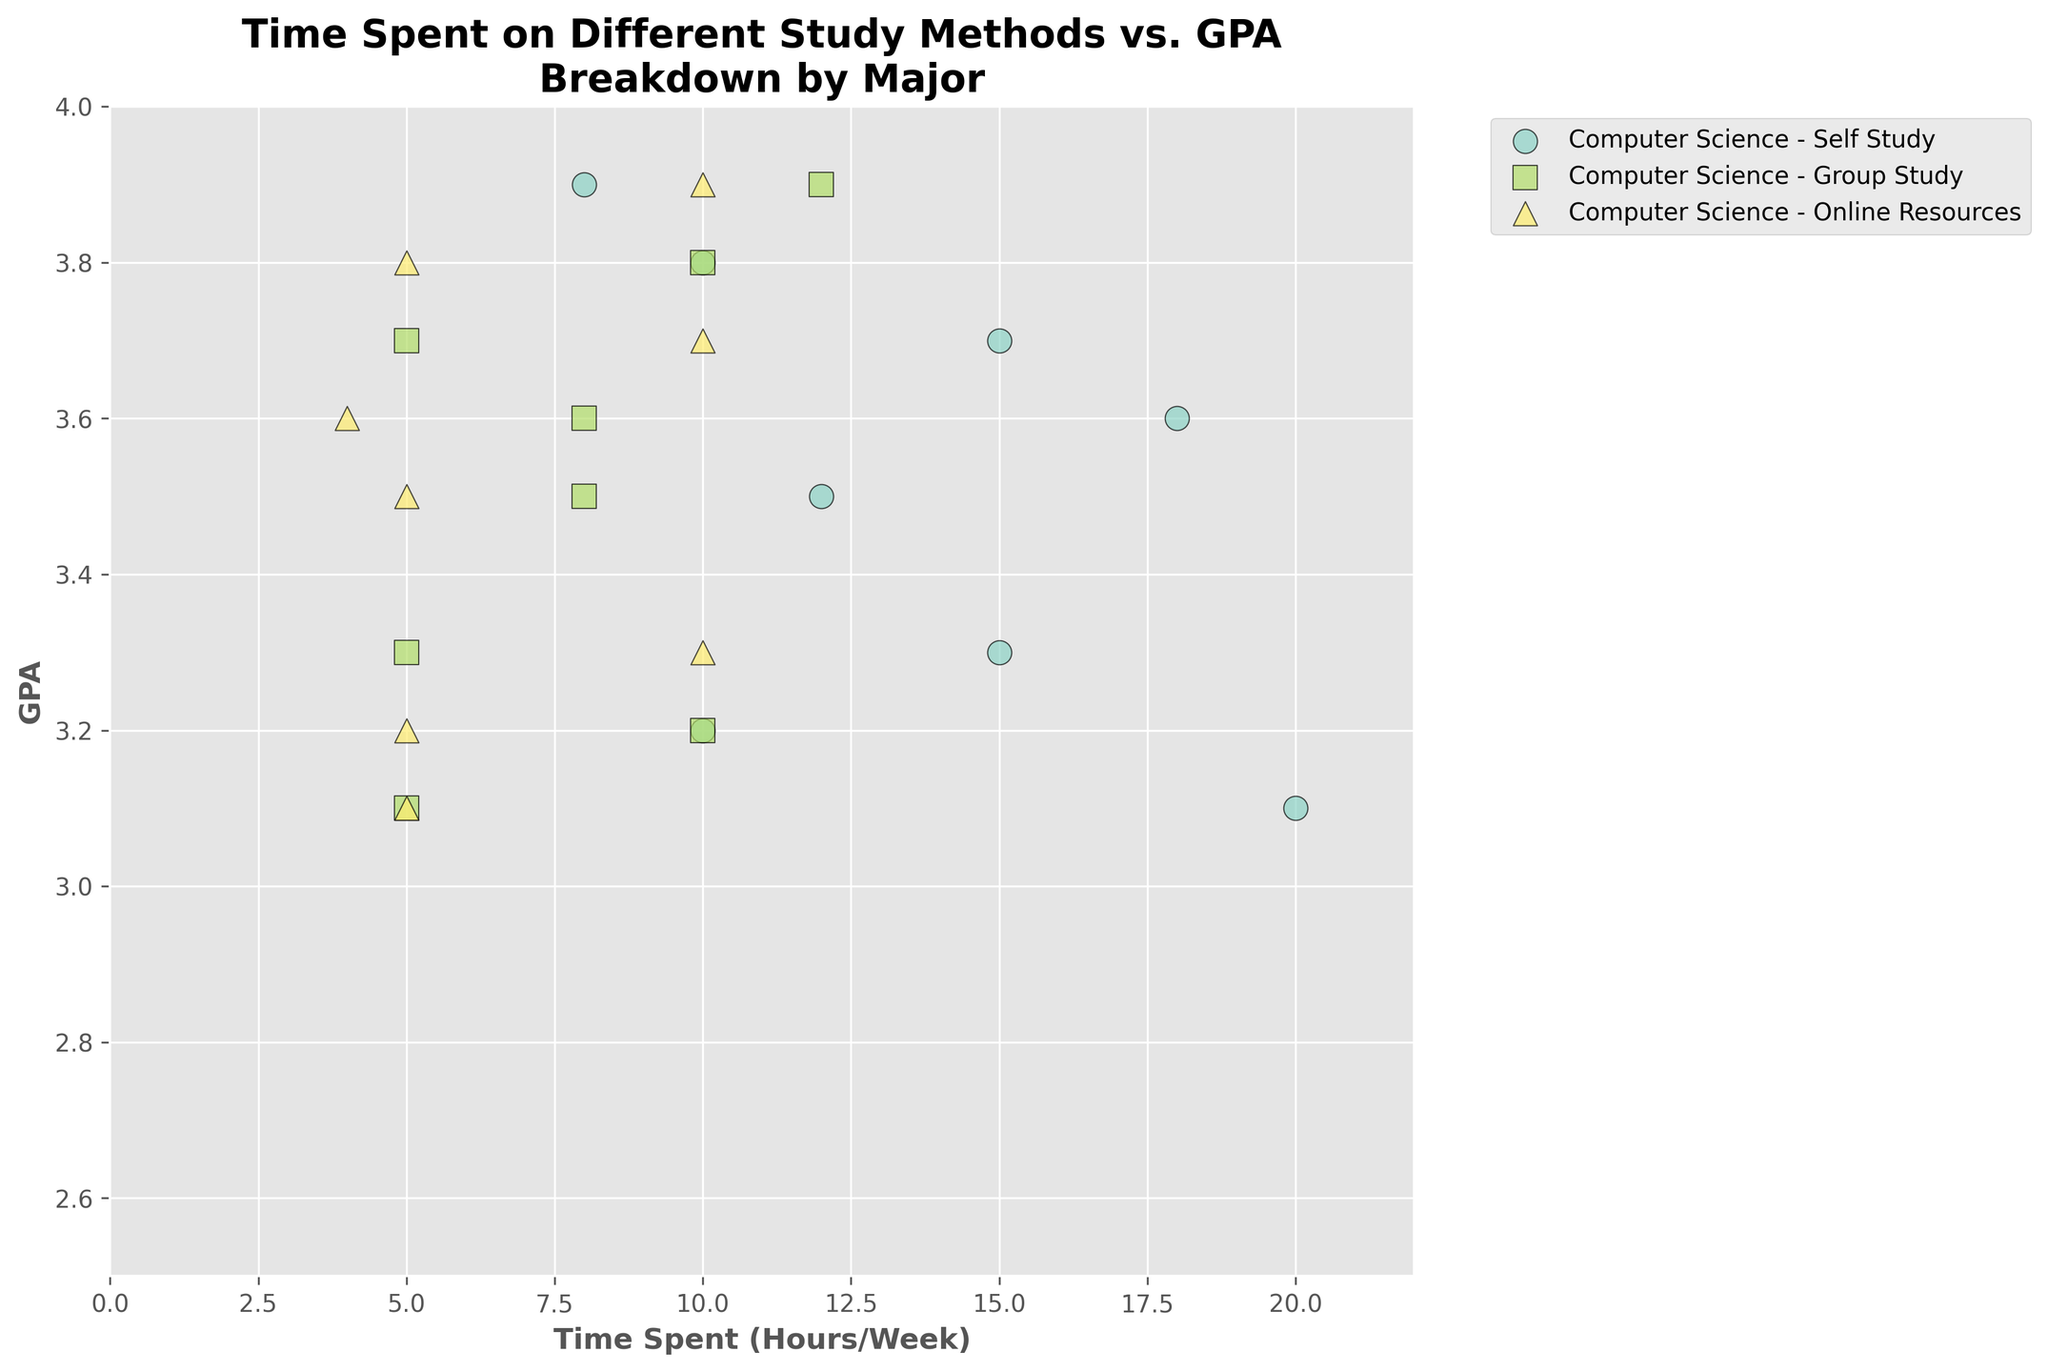What is the title of the scatter plot? The title of the scatter plot is a text element that usually appears on top of the chart, summarizing the content or main point of the chart. In this case, the title is "Time Spent on Different Study Methods vs. GPA\nBreakdown by Major".
Answer: Time Spent on Different Study Methods vs. GPA\nBreakdown by Major What are the labels for the x-axis and y-axis? The labels of the axes are text elements that describe what each axis represents. For the x-axis, it is "Time Spent (Hours/Week)" and for the y-axis, it is "GPA".
Answer: Time Spent (Hours/Week) for x-axis, GPA for y-axis Which major has the highest average GPA for students using online resources? To find this, look at the GPA values for each major specifically for the study method 'Online Resources'. The data points for different majors are color-coded, and the specific study method is differentiated by markers. The Psychology and English Literature students have the highest GPA (3.9 and 3.8 respectively) when using online resources.
Answer: Psychology How many study methods are broken down in the plot? The number of distinct study methods can be identified by observing the unique markers used in the scatter plot. According to the legend and markers, there are three study methods: Self Study, Group Study, and Online Resources.
Answer: 3 Which major spends the most time on self-study, and how much time do they spend? To determine this, find the data points related to 'Self Study' for each major and identify the one with the highest x-value. According to the plot, Mechanical Engineering students spend the most time on self-study, with a value of 20 hours per week.
Answer: Mechanical Engineering, 20 hours Is there a positive or negative correlation between time spent on group study and GPA for Business Administration students? Examine the data points for Business Administration students that reflect 'Group Study'. The time spent on group study (10 hours) and the corresponding GPA (3.2) indicate a specific point on the chart. Due to only one data point, it is neither distinctly positive nor negative but rather neutral.
Answer: Neutral Which study method seems to have the widest range of time spent across all majors? Observe the spread of data points for each study method regarding the x-axis (time spent). 'Self Study' shows the widest range, from 8 to 20 hours per week.
Answer: Self Study Do Chemistry students spend more or less time on online resources compared to self-study? Compare the x-values of Chemistry students’ data points for 'Self Study' and 'Online Resources'. They spend 18 hours on self-study and 4 hours on online resources, indicating they spend more time on self-study.
Answer: More Are the GPA values for students with the same major and study method identical or varying? Check if the GPA values for students with the same major and study method are the same or differ. For example, all data points for one major and one study method (like Computer Science – Self Study) have identical GPA values within that group.
Answer: Identical 